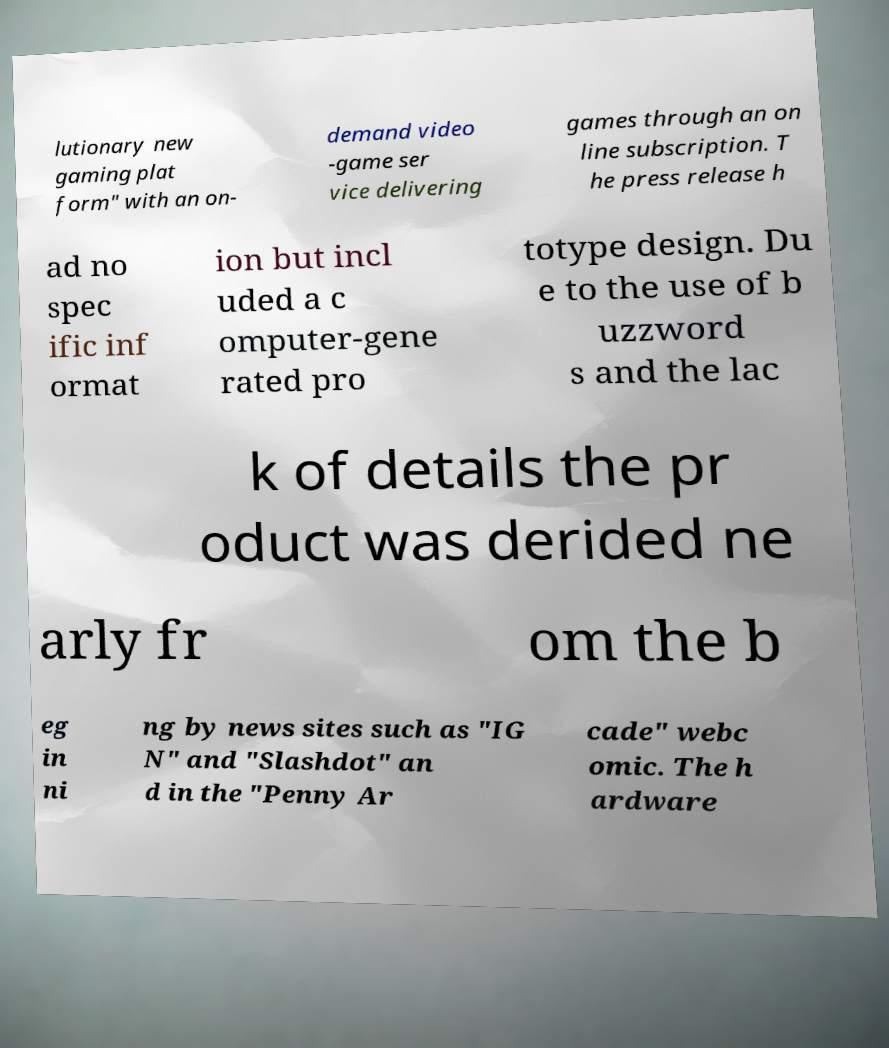What messages or text are displayed in this image? I need them in a readable, typed format. lutionary new gaming plat form" with an on- demand video -game ser vice delivering games through an on line subscription. T he press release h ad no spec ific inf ormat ion but incl uded a c omputer-gene rated pro totype design. Du e to the use of b uzzword s and the lac k of details the pr oduct was derided ne arly fr om the b eg in ni ng by news sites such as "IG N" and "Slashdot" an d in the "Penny Ar cade" webc omic. The h ardware 